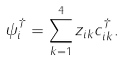Convert formula to latex. <formula><loc_0><loc_0><loc_500><loc_500>\psi _ { i } ^ { \dagger } = \sum _ { k = 1 } ^ { 4 } z _ { i k } c ^ { \dagger } _ { i k } .</formula> 